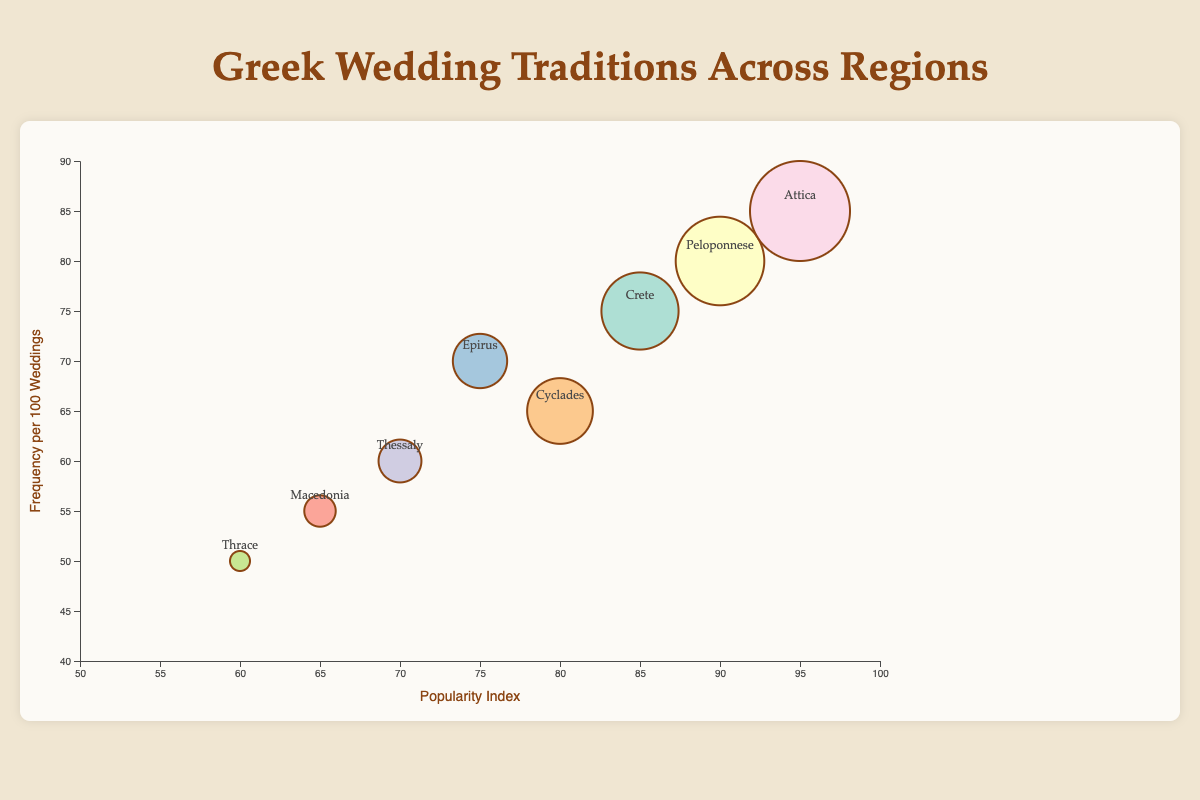What is the title of the bubble chart? The title is clearly stated at the top of the chart in a large font size and distinct color.
Answer: Greek Wedding Traditions Across Regions Which region has the highest popularity index? By looking at the x-axis values, the region with the highest x value corresponds to the region with the highest popularity index. The furthest point to the right represents the highest popularity index.
Answer: Attica How many traditions have a frequency per 100 weddings greater than 70? To find the number of traditions with frequency greater than 70, locate bubbles above the 70 mark on the y-axis. Count these bubbles.
Answer: 3 Which tradition in the bubble chart has the largest average impact score? The size of the bubble represents the average impact score. The largest bubble, determined visually, corresponds to the highest average impact score.
Answer: Stefana (Wedding Crowns) Compare the frequency per 100 weddings of Crete and Epirus traditions. Identify the positions of Crete and Epirus on the y-axis. Look at their respective bubbles and compare their y values to determine which is higher.
Answer: Epirus (70) is higher than Crete (75) What is the difference in popularity index between the Peloponnese and Thessaly regions? Find the x-coordinates for the Peloponnese and Thessaly regions and calculate the difference between them. Peloponnese: 90, Thessaly: 70.
Answer: 20 Which tradition from the Cyclades region has the displayed information? Locate the bubble for the Cyclades region and hover over or reference its label to see the associated tradition.
Answer: Offering of Wine and Bread What is the most common visual characteristic that indicates a higher average impact score? Higher average impact scores are represented by larger bubble sizes.
Answer: Larger bubble size Which region has the lowest frequency per 100 weddings? To find this, look for the bubble positioned lowest on the y-axis, which corresponds to the lowest frequency per 100 weddings.
Answer: Thrace Calculate the average popularity index for the regions of Attica, Peloponnese, and Crete. Add the popularity indices of Attica (95), Peloponnese (90), and Crete (85) and then divide by 3.
Answer: (95 + 90 + 85) / 3 = 90 